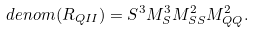Convert formula to latex. <formula><loc_0><loc_0><loc_500><loc_500>d e n o m ( R _ { Q I I } ) = S ^ { 3 } M _ { S } ^ { 3 } M ^ { 2 } _ { S S } M ^ { 2 } _ { Q Q } .</formula> 